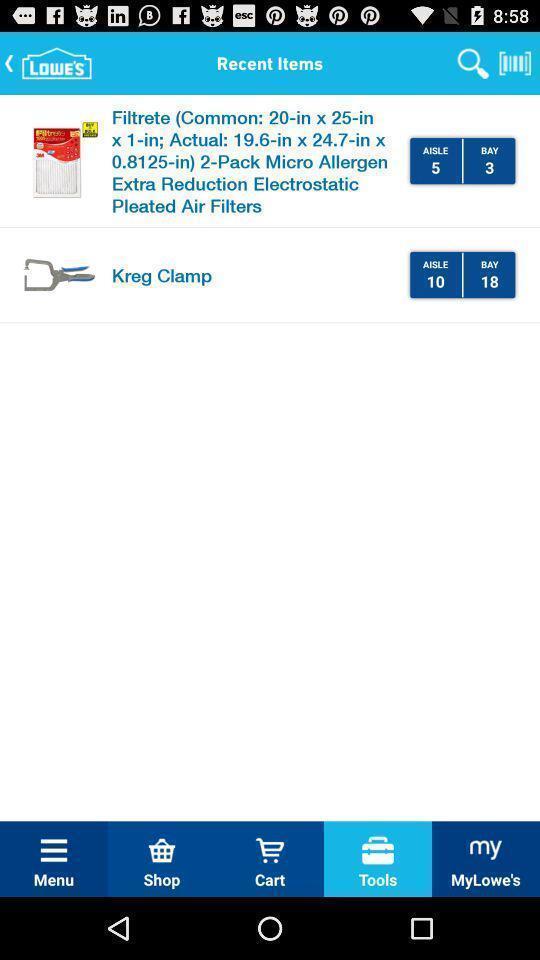Give me a narrative description of this picture. Some kinds of recent products in the online shopping application. 